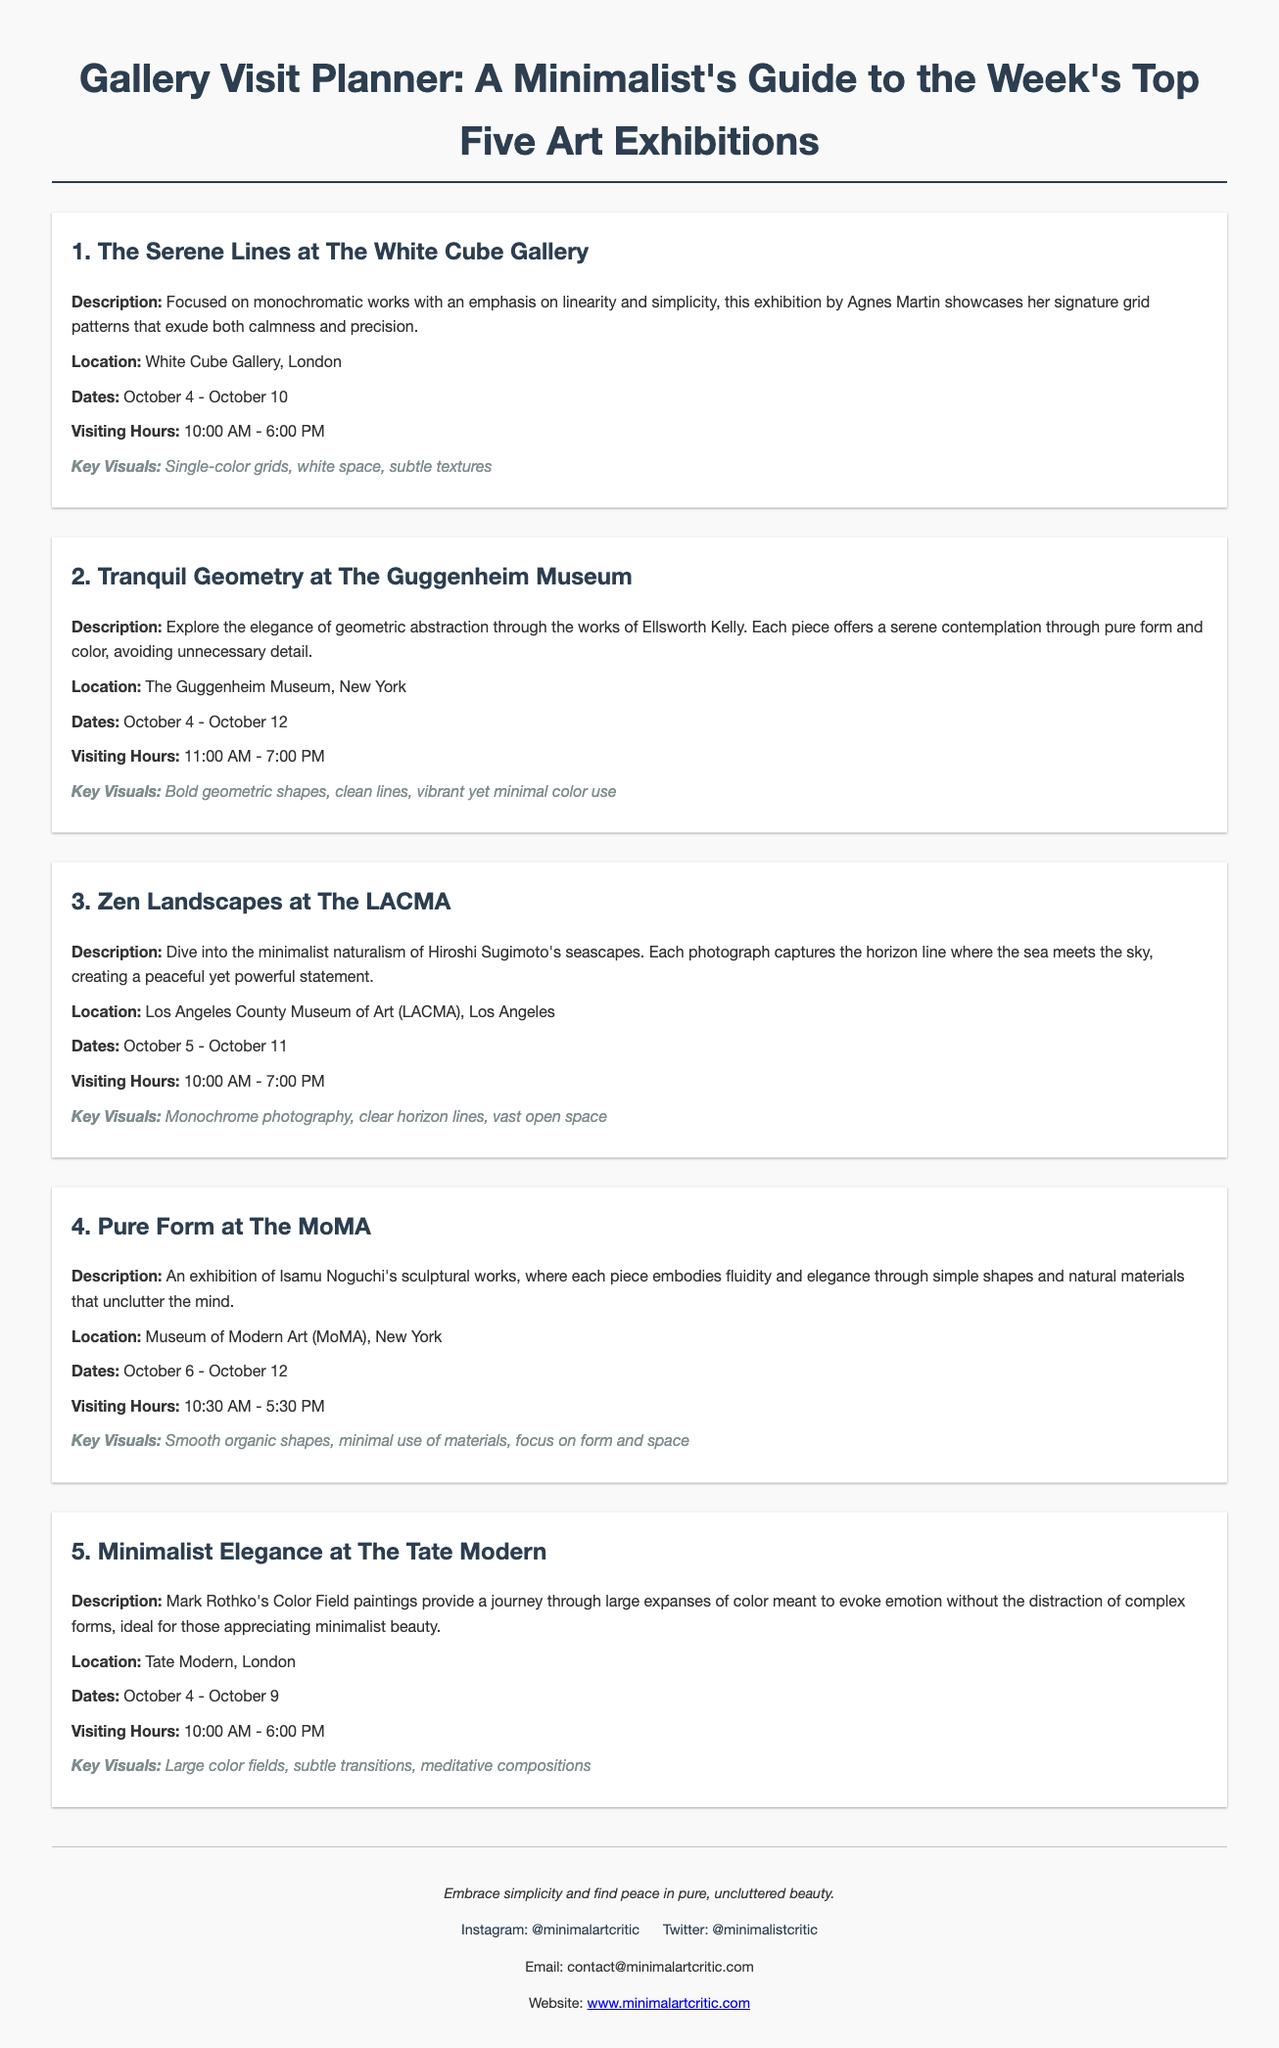What is the title of the infographic? The title of the infographic is the text presented prominently at the top, summarizing the content of the document.
Answer: Gallery Visit Planner: A Minimalist's Guide to the Week's Top Five Art Exhibitions How many art exhibitions are featured in this guide? The guide explicitly lists the number of featured exhibitions in its introductory text.
Answer: Five Where is "Zen Landscapes" located? The location of the "Zen Landscapes" exhibition is provided in the description of that particular exhibition.
Answer: Los Angeles County Museum of Art (LACMA) What are the visiting hours for "Pure Form"? The visiting hours for the "Pure Form" exhibition are stated clearly in its section.
Answer: 10:30 AM - 5:30 PM Which artist is associated with "The Serene Lines"? The name of the artist responsible for "The Serene Lines" is mentioned within that exhibition’s description.
Answer: Agnes Martin What is the common theme across the exhibitions? The common theme can be inferred from the descriptions emphasizing simplicity and minimalism in art.
Answer: Minimalism When does "Minimalist Elegance" run? The dates for the "Minimalist Elegance" exhibition are specifically outlined in its section in the document.
Answer: October 4 - October 9 What type of visuals does "Tranquil Geometry" feature? The key visuals for the "Tranquil Geometry" exhibition are detailed to highlight its distinguishing characteristics.
Answer: Bold geometric shapes, clean lines, vibrant yet minimal color use What is the main focus of the infographic? The primary focus is encapsulated in the introductory title, explaining the purpose of the guide.
Answer: Simplicity and pure, uncluttered beauty 